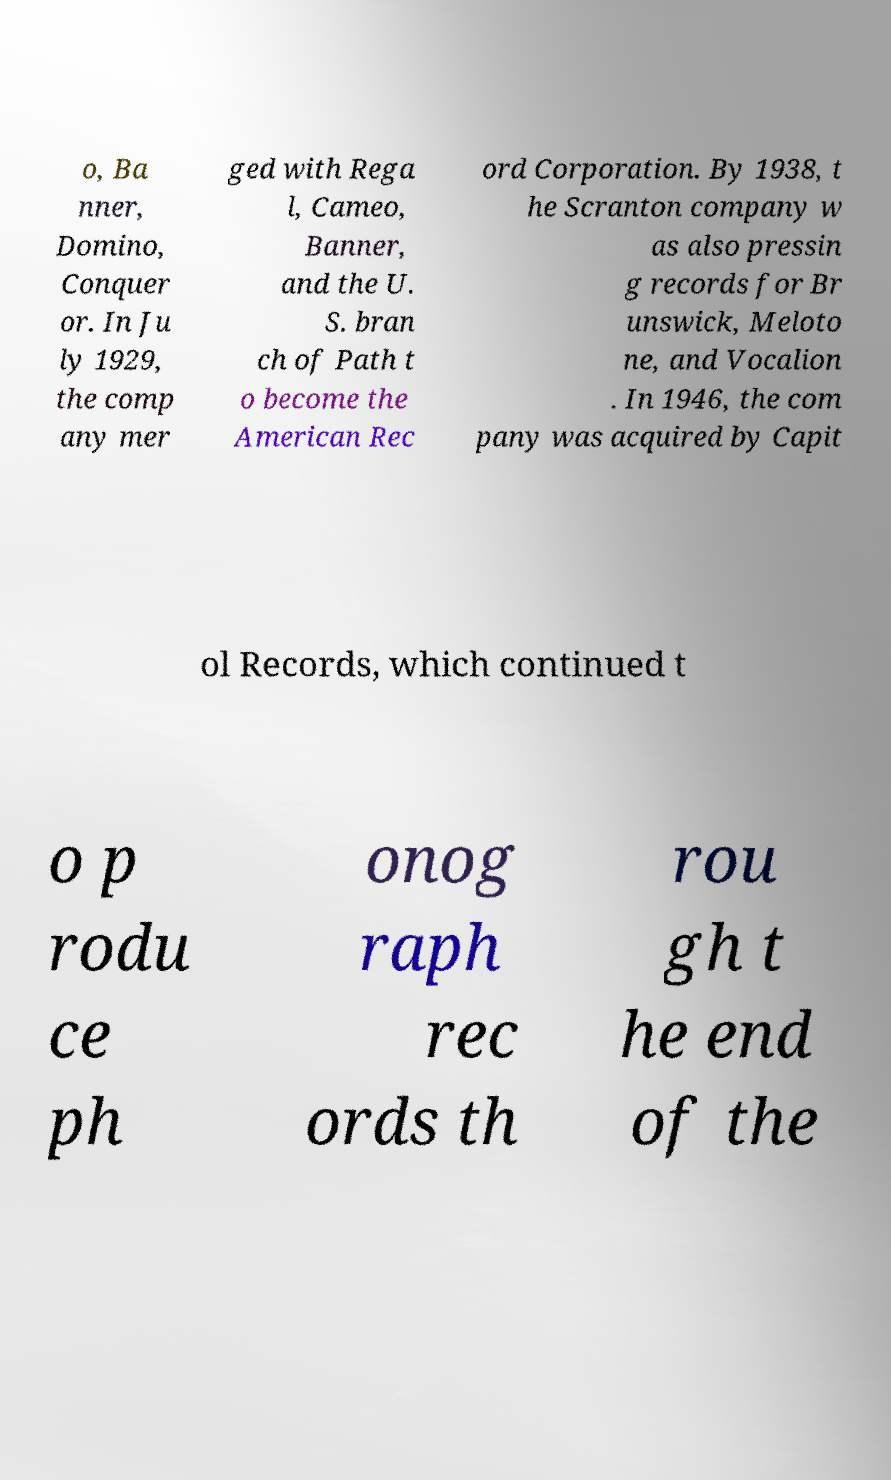There's text embedded in this image that I need extracted. Can you transcribe it verbatim? o, Ba nner, Domino, Conquer or. In Ju ly 1929, the comp any mer ged with Rega l, Cameo, Banner, and the U. S. bran ch of Path t o become the American Rec ord Corporation. By 1938, t he Scranton company w as also pressin g records for Br unswick, Meloto ne, and Vocalion . In 1946, the com pany was acquired by Capit ol Records, which continued t o p rodu ce ph onog raph rec ords th rou gh t he end of the 